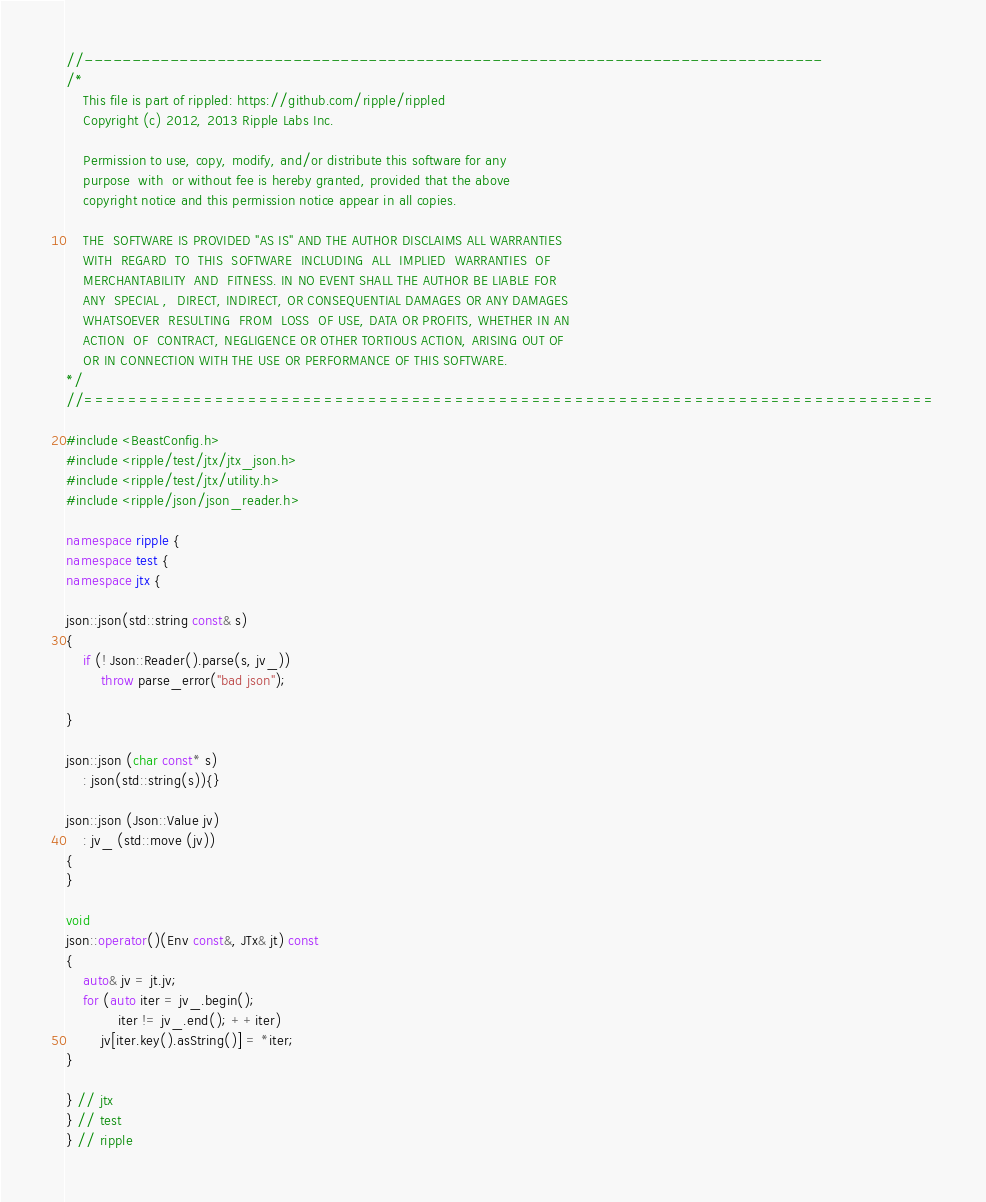Convert code to text. <code><loc_0><loc_0><loc_500><loc_500><_C++_>//------------------------------------------------------------------------------
/*
    This file is part of rippled: https://github.com/ripple/rippled
    Copyright (c) 2012, 2013 Ripple Labs Inc.

    Permission to use, copy, modify, and/or distribute this software for any
    purpose  with  or without fee is hereby granted, provided that the above
    copyright notice and this permission notice appear in all copies.

    THE  SOFTWARE IS PROVIDED "AS IS" AND THE AUTHOR DISCLAIMS ALL WARRANTIES
    WITH  REGARD  TO  THIS  SOFTWARE  INCLUDING  ALL  IMPLIED  WARRANTIES  OF
    MERCHANTABILITY  AND  FITNESS. IN NO EVENT SHALL THE AUTHOR BE LIABLE FOR
    ANY  SPECIAL ,  DIRECT, INDIRECT, OR CONSEQUENTIAL DAMAGES OR ANY DAMAGES
    WHATSOEVER  RESULTING  FROM  LOSS  OF USE, DATA OR PROFITS, WHETHER IN AN
    ACTION  OF  CONTRACT, NEGLIGENCE OR OTHER TORTIOUS ACTION, ARISING OUT OF
    OR IN CONNECTION WITH THE USE OR PERFORMANCE OF THIS SOFTWARE.
*/
//==============================================================================

#include <BeastConfig.h>
#include <ripple/test/jtx/jtx_json.h>
#include <ripple/test/jtx/utility.h>
#include <ripple/json/json_reader.h>

namespace ripple {
namespace test {
namespace jtx {

json::json(std::string const& s)
{
    if (! Json::Reader().parse(s, jv_))
        throw parse_error("bad json");

}

json::json (char const* s)
    : json(std::string(s)){}

json::json (Json::Value jv)
    : jv_ (std::move (jv))
{
}

void
json::operator()(Env const&, JTx& jt) const
{
    auto& jv = jt.jv;
    for (auto iter = jv_.begin();
            iter != jv_.end(); ++iter)
        jv[iter.key().asString()] = *iter;
}

} // jtx
} // test
} // ripple
</code> 